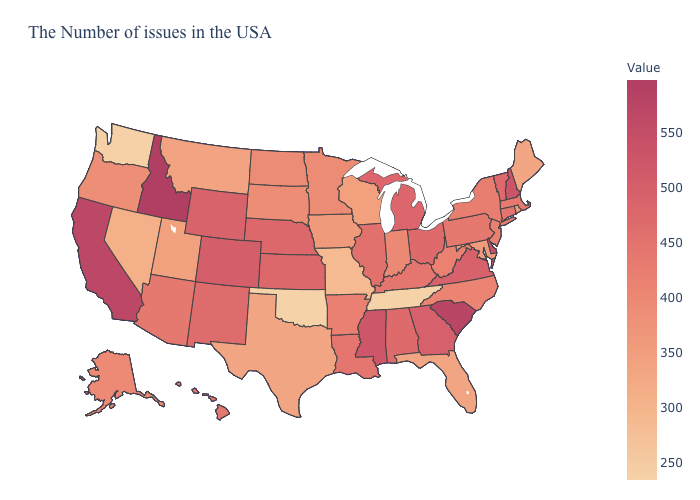Among the states that border South Carolina , which have the highest value?
Write a very short answer. Georgia. Among the states that border Illinois , which have the lowest value?
Give a very brief answer. Missouri. Does the map have missing data?
Keep it brief. No. Does Maryland have a lower value than South Carolina?
Quick response, please. Yes. Is the legend a continuous bar?
Answer briefly. Yes. 